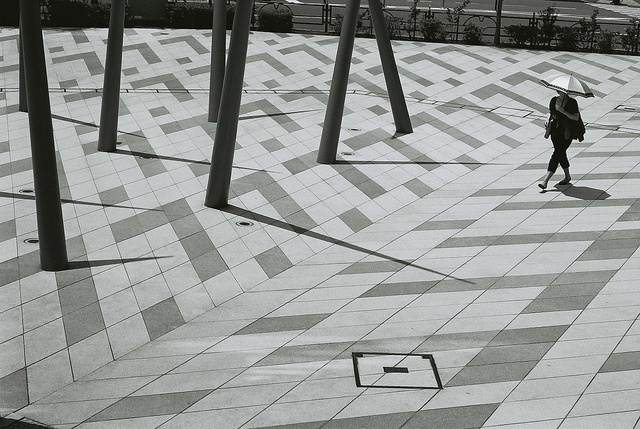Describe the objects in this image and their specific colors. I can see people in black, gray, and darkgray tones, umbrella in black, lightgray, darkgray, and gray tones, handbag in black, gray, darkgray, and lightgray tones, and handbag in black, gray, darkgray, and lightgray tones in this image. 